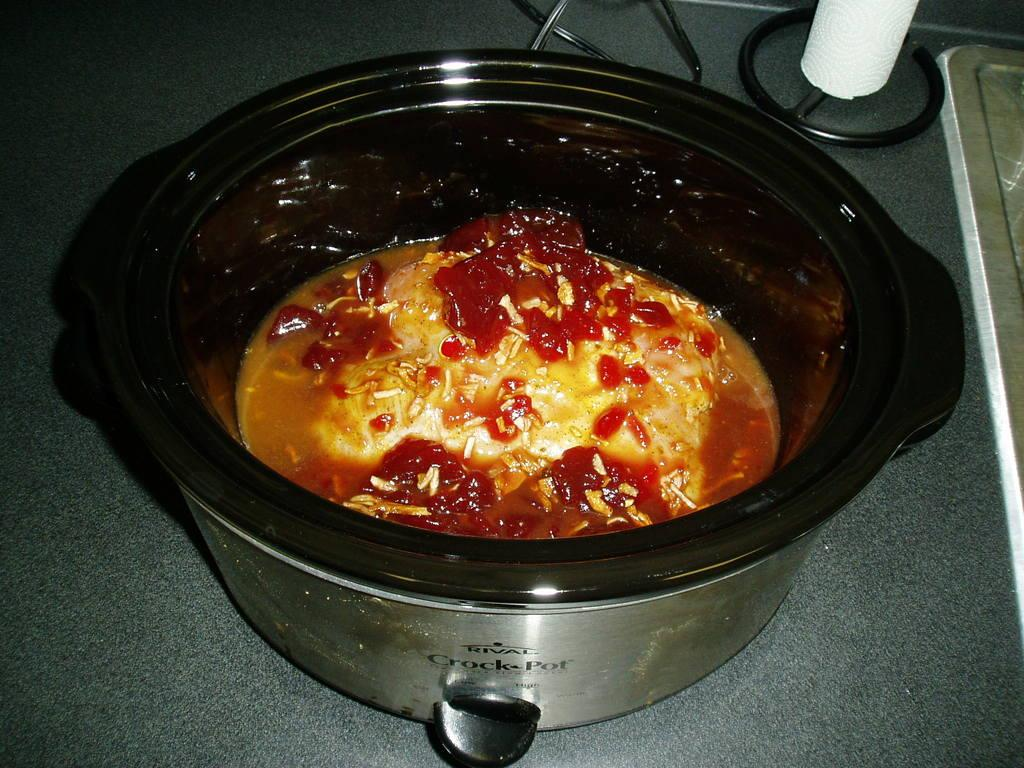What is in the bowl that is visible in the image? The bowl contains food items. Can you describe any other objects visible in the image? There are other objects visible at the top of the image. What level of the lake is shown in the image? There is no lake present in the image, so it is not possible to determine the level. 